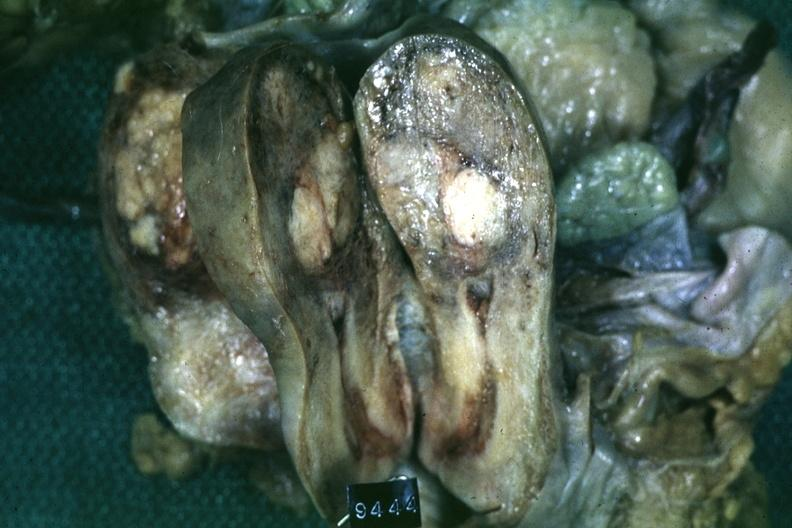s dysplastic present?
Answer the question using a single word or phrase. No 